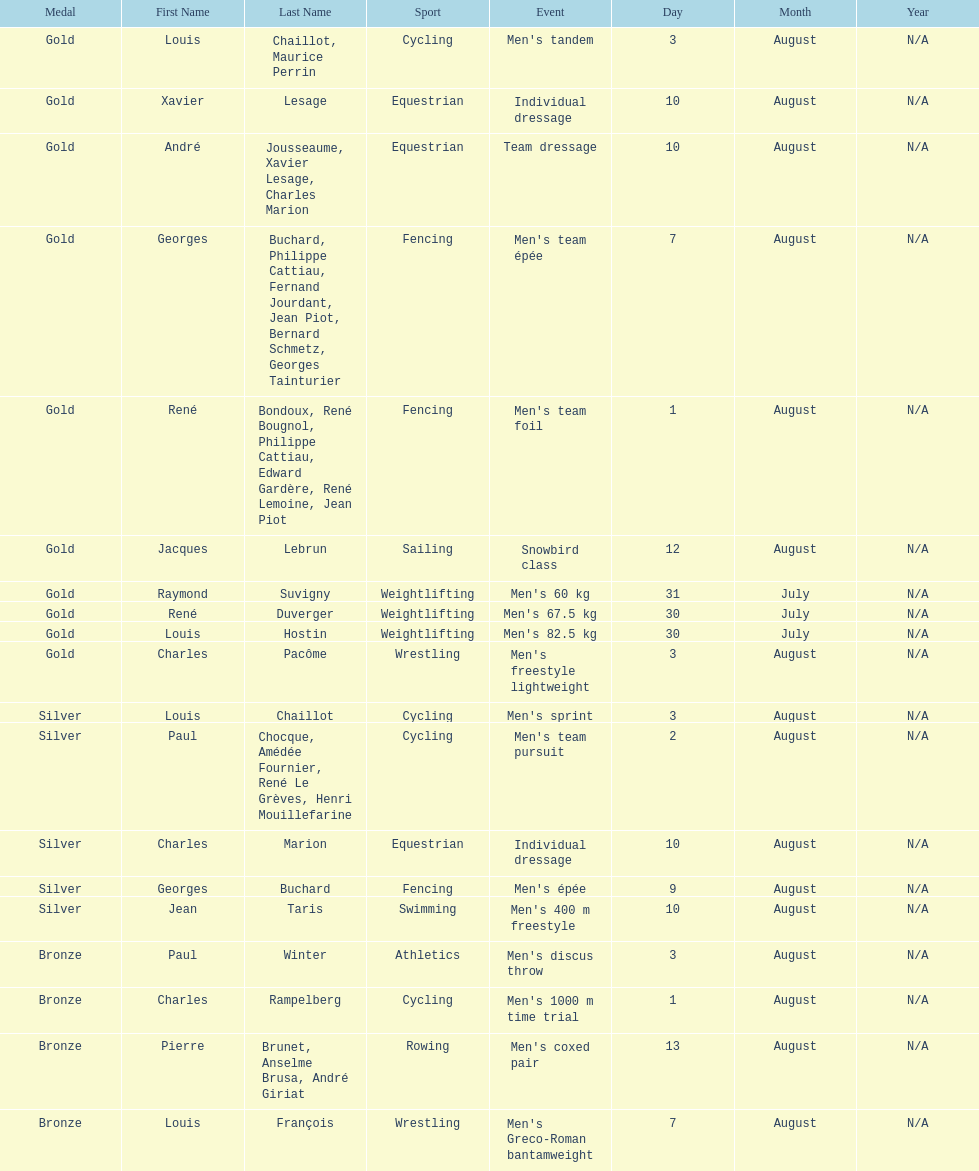How many gold medals did this country win during these olympics? 10. 